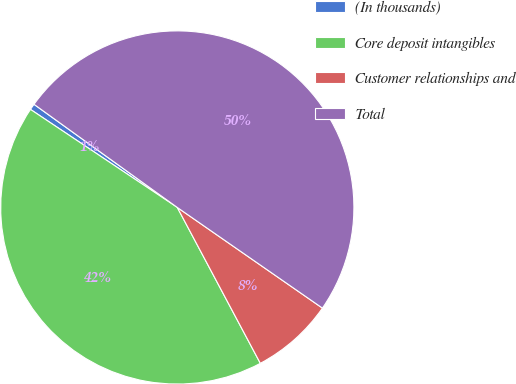Convert chart to OTSL. <chart><loc_0><loc_0><loc_500><loc_500><pie_chart><fcel>(In thousands)<fcel>Core deposit intangibles<fcel>Customer relationships and<fcel>Total<nl><fcel>0.56%<fcel>42.16%<fcel>7.56%<fcel>49.72%<nl></chart> 